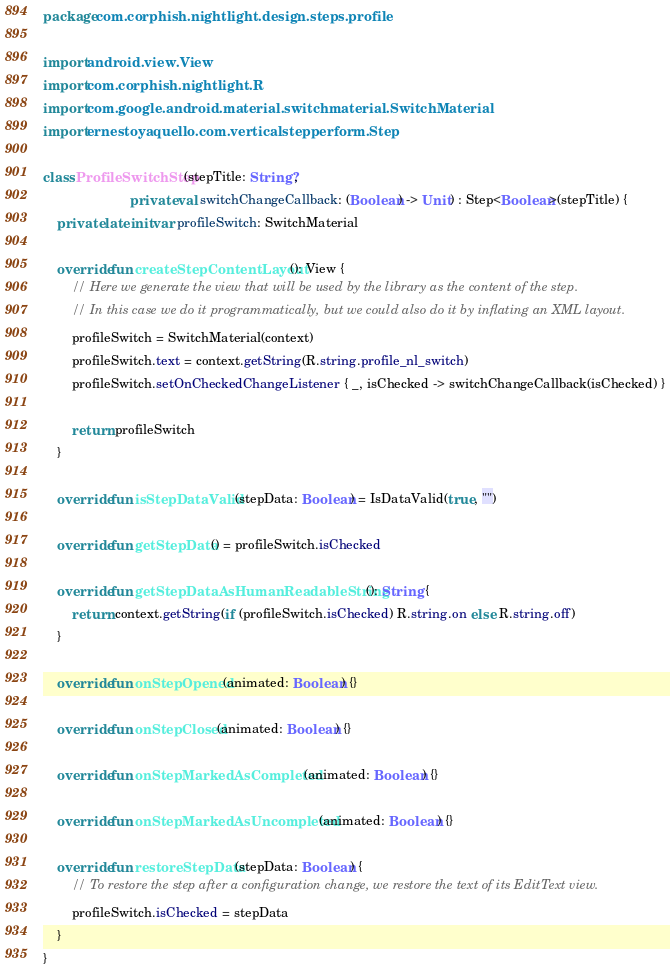<code> <loc_0><loc_0><loc_500><loc_500><_Kotlin_>package com.corphish.nightlight.design.steps.profile

import android.view.View
import com.corphish.nightlight.R
import com.google.android.material.switchmaterial.SwitchMaterial
import ernestoyaquello.com.verticalstepperform.Step

class ProfileSwitchStep(stepTitle: String?,
                        private val switchChangeCallback: (Boolean) -> Unit) : Step<Boolean>(stepTitle) {
    private lateinit var profileSwitch: SwitchMaterial

    override fun createStepContentLayout(): View {
        // Here we generate the view that will be used by the library as the content of the step.
        // In this case we do it programmatically, but we could also do it by inflating an XML layout.
        profileSwitch = SwitchMaterial(context)
        profileSwitch.text = context.getString(R.string.profile_nl_switch)
        profileSwitch.setOnCheckedChangeListener { _, isChecked -> switchChangeCallback(isChecked) }

        return profileSwitch
    }

    override fun isStepDataValid(stepData: Boolean) = IsDataValid(true, "")

    override fun getStepData() = profileSwitch.isChecked

    override fun getStepDataAsHumanReadableString(): String {
        return context.getString(if (profileSwitch.isChecked) R.string.on else R.string.off)
    }

    override fun onStepOpened(animated: Boolean) {}

    override fun onStepClosed(animated: Boolean) {}

    override fun onStepMarkedAsCompleted(animated: Boolean) {}

    override fun onStepMarkedAsUncompleted(animated: Boolean) {}

    override fun restoreStepData(stepData: Boolean) {
        // To restore the step after a configuration change, we restore the text of its EditText view.
        profileSwitch.isChecked = stepData
    }
}</code> 